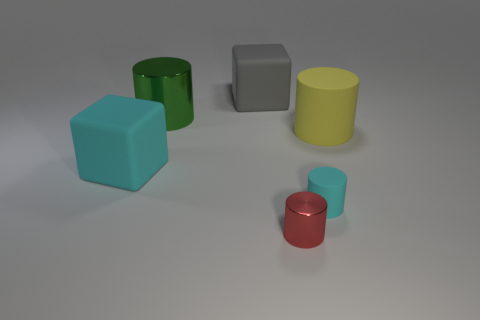Subtract all brown cylinders. Subtract all green cubes. How many cylinders are left? 4 Add 1 big yellow matte things. How many objects exist? 7 Subtract all cubes. How many objects are left? 4 Subtract 0 yellow cubes. How many objects are left? 6 Subtract all large yellow objects. Subtract all large yellow cylinders. How many objects are left? 4 Add 2 matte cylinders. How many matte cylinders are left? 4 Add 4 large red metallic spheres. How many large red metallic spheres exist? 4 